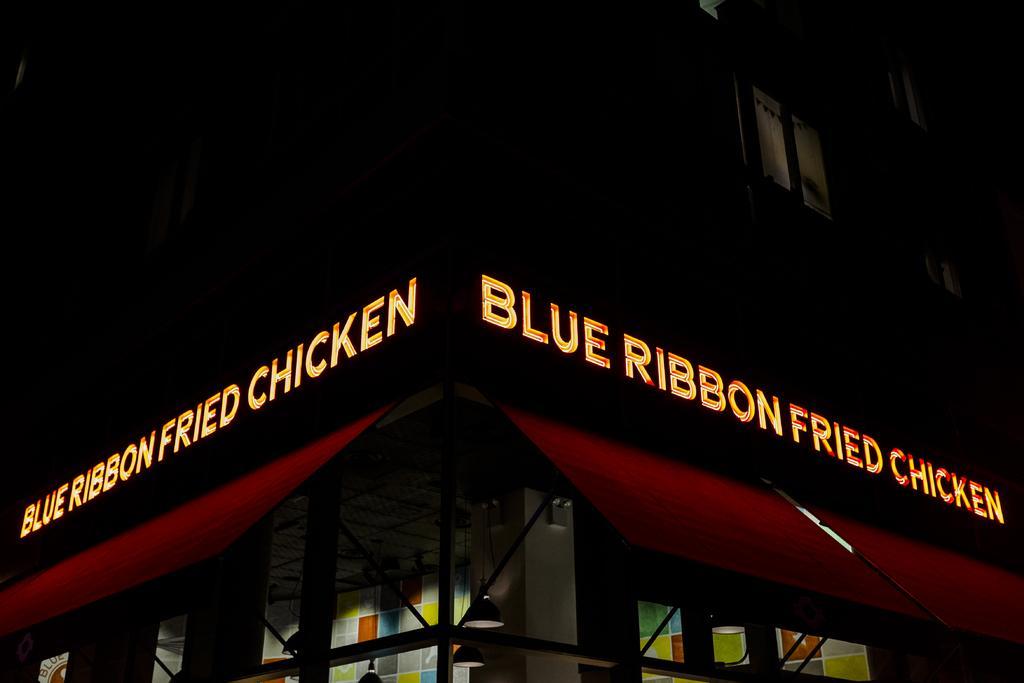In one or two sentences, can you explain what this image depicts? In this picture we can see a building and a few windows on it. We can see some text on this building. 